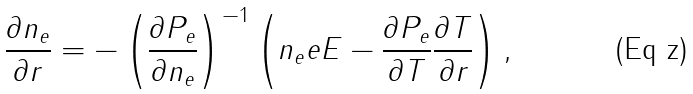Convert formula to latex. <formula><loc_0><loc_0><loc_500><loc_500>\frac { \partial n _ { e } } { \partial r } = - \left ( \frac { \partial P _ { e } } { \partial n _ { e } } \right ) ^ { - 1 } \left ( n _ { e } e E - \frac { \partial P _ { e } } { \partial T } \frac { \partial T } { \partial r } \right ) ,</formula> 